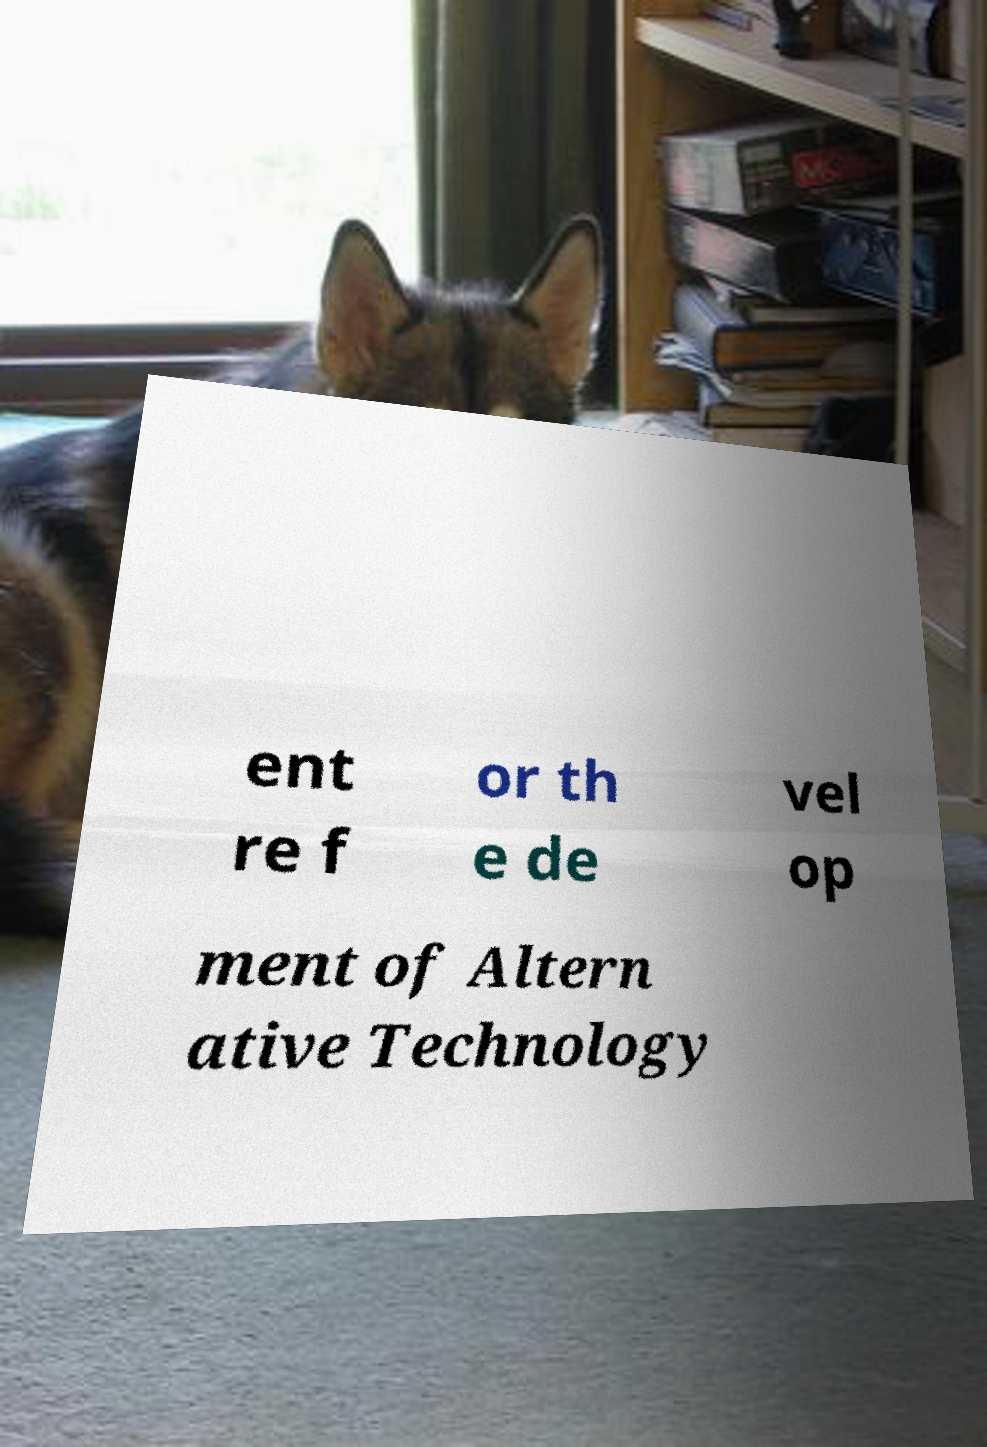Could you extract and type out the text from this image? ent re f or th e de vel op ment of Altern ative Technology 